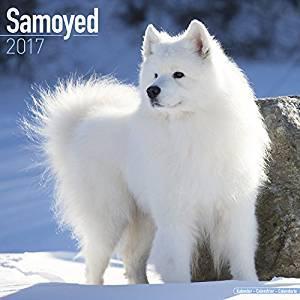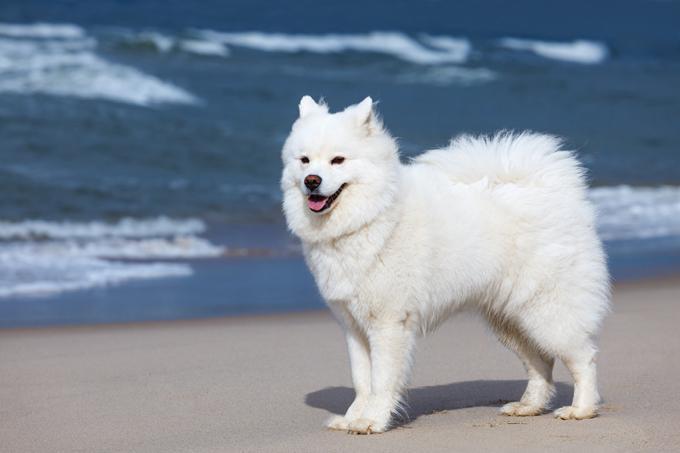The first image is the image on the left, the second image is the image on the right. Assess this claim about the two images: "At least one dog is standing on asphalt.". Correct or not? Answer yes or no. No. 